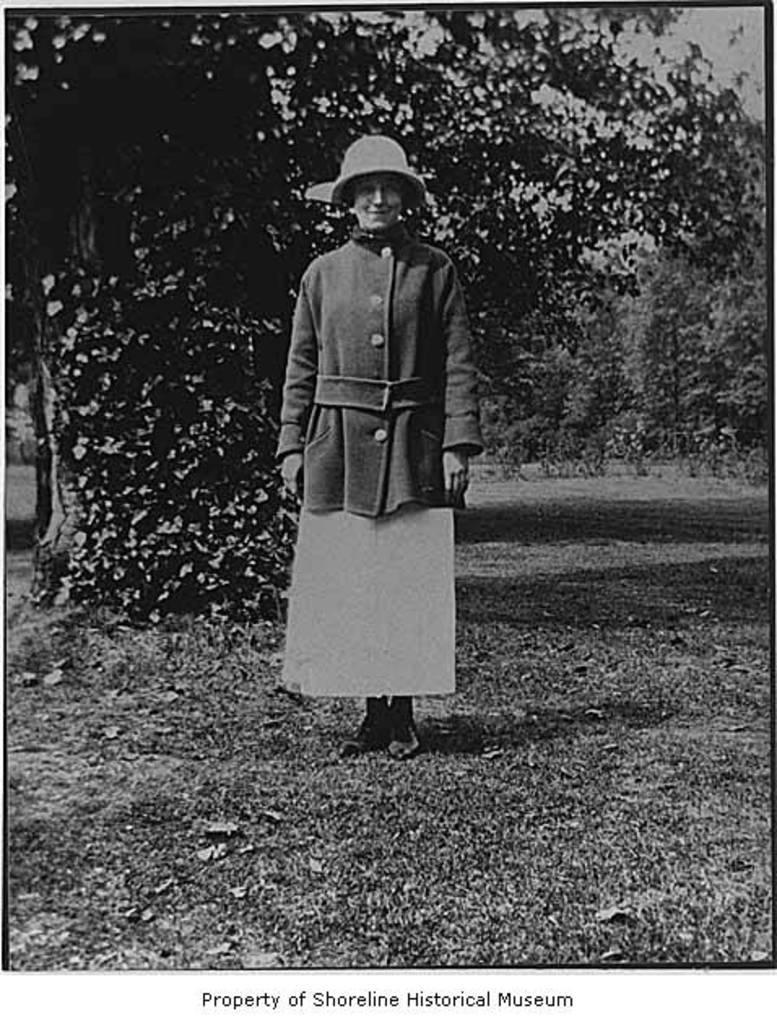In one or two sentences, can you explain what this image depicts? This is a black and white photo. We can see a person standing and smiling. We can see a few trees in the background. There is a text at the bottom of an image. 